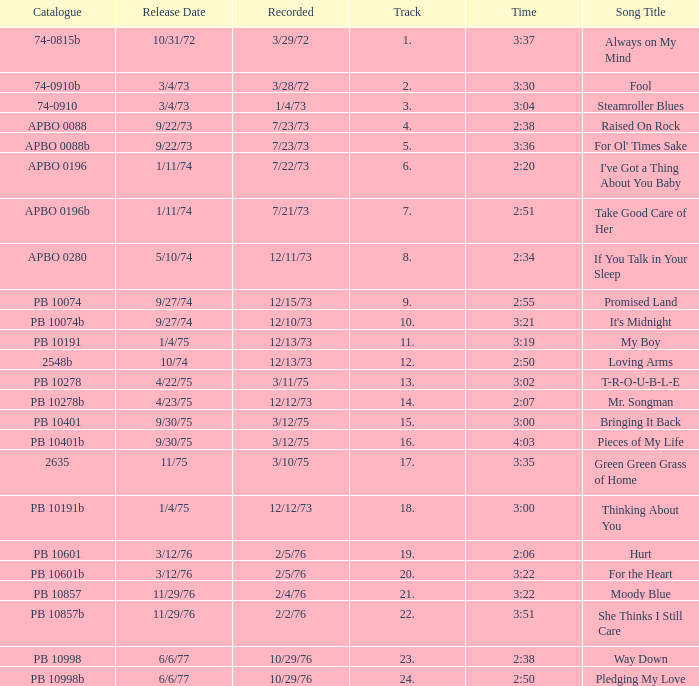Tell me the time for 6/6/77 release date and song title of way down 2:38. 